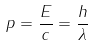Convert formula to latex. <formula><loc_0><loc_0><loc_500><loc_500>p = { \frac { E } { c } } = { \frac { h } { \lambda } }</formula> 